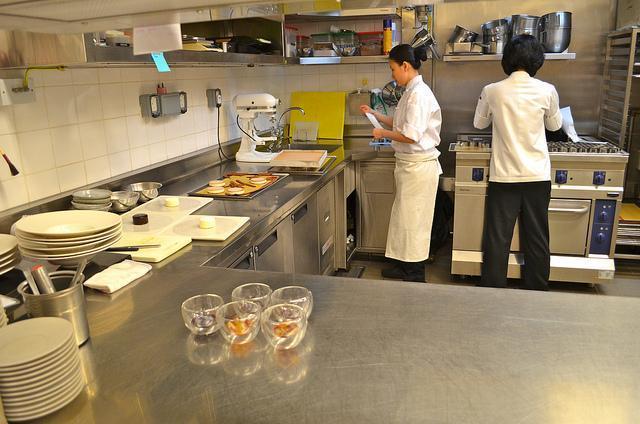How many clear glass bowls are on the counter?
Give a very brief answer. 5. How many people are there?
Give a very brief answer. 2. How many holes are in the toilet bowl?
Give a very brief answer. 0. 